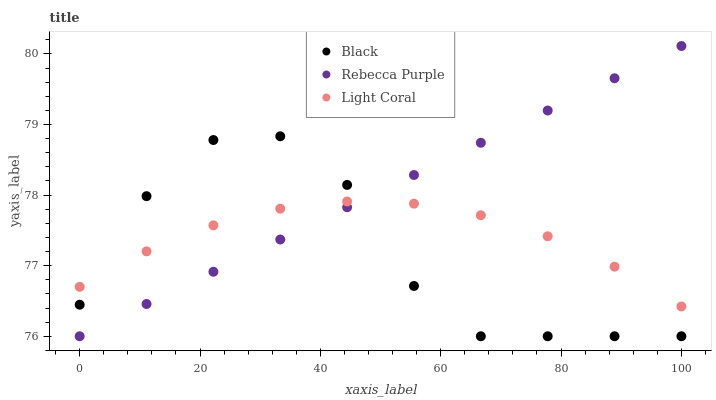Does Black have the minimum area under the curve?
Answer yes or no. Yes. Does Rebecca Purple have the maximum area under the curve?
Answer yes or no. Yes. Does Rebecca Purple have the minimum area under the curve?
Answer yes or no. No. Does Black have the maximum area under the curve?
Answer yes or no. No. Is Rebecca Purple the smoothest?
Answer yes or no. Yes. Is Black the roughest?
Answer yes or no. Yes. Is Black the smoothest?
Answer yes or no. No. Is Rebecca Purple the roughest?
Answer yes or no. No. Does Black have the lowest value?
Answer yes or no. Yes. Does Rebecca Purple have the highest value?
Answer yes or no. Yes. Does Black have the highest value?
Answer yes or no. No. Does Black intersect Light Coral?
Answer yes or no. Yes. Is Black less than Light Coral?
Answer yes or no. No. Is Black greater than Light Coral?
Answer yes or no. No. 